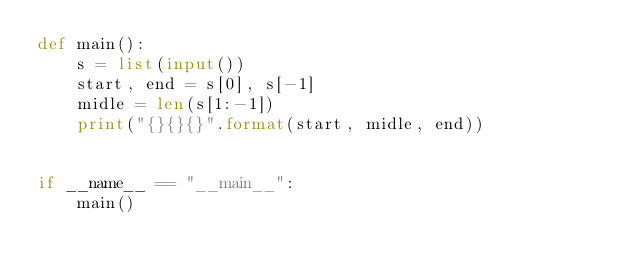Convert code to text. <code><loc_0><loc_0><loc_500><loc_500><_Python_>def main():
    s = list(input())
    start, end = s[0], s[-1]
    midle = len(s[1:-1])
    print("{}{}{}".format(start, midle, end))


if __name__ == "__main__":
    main()
</code> 